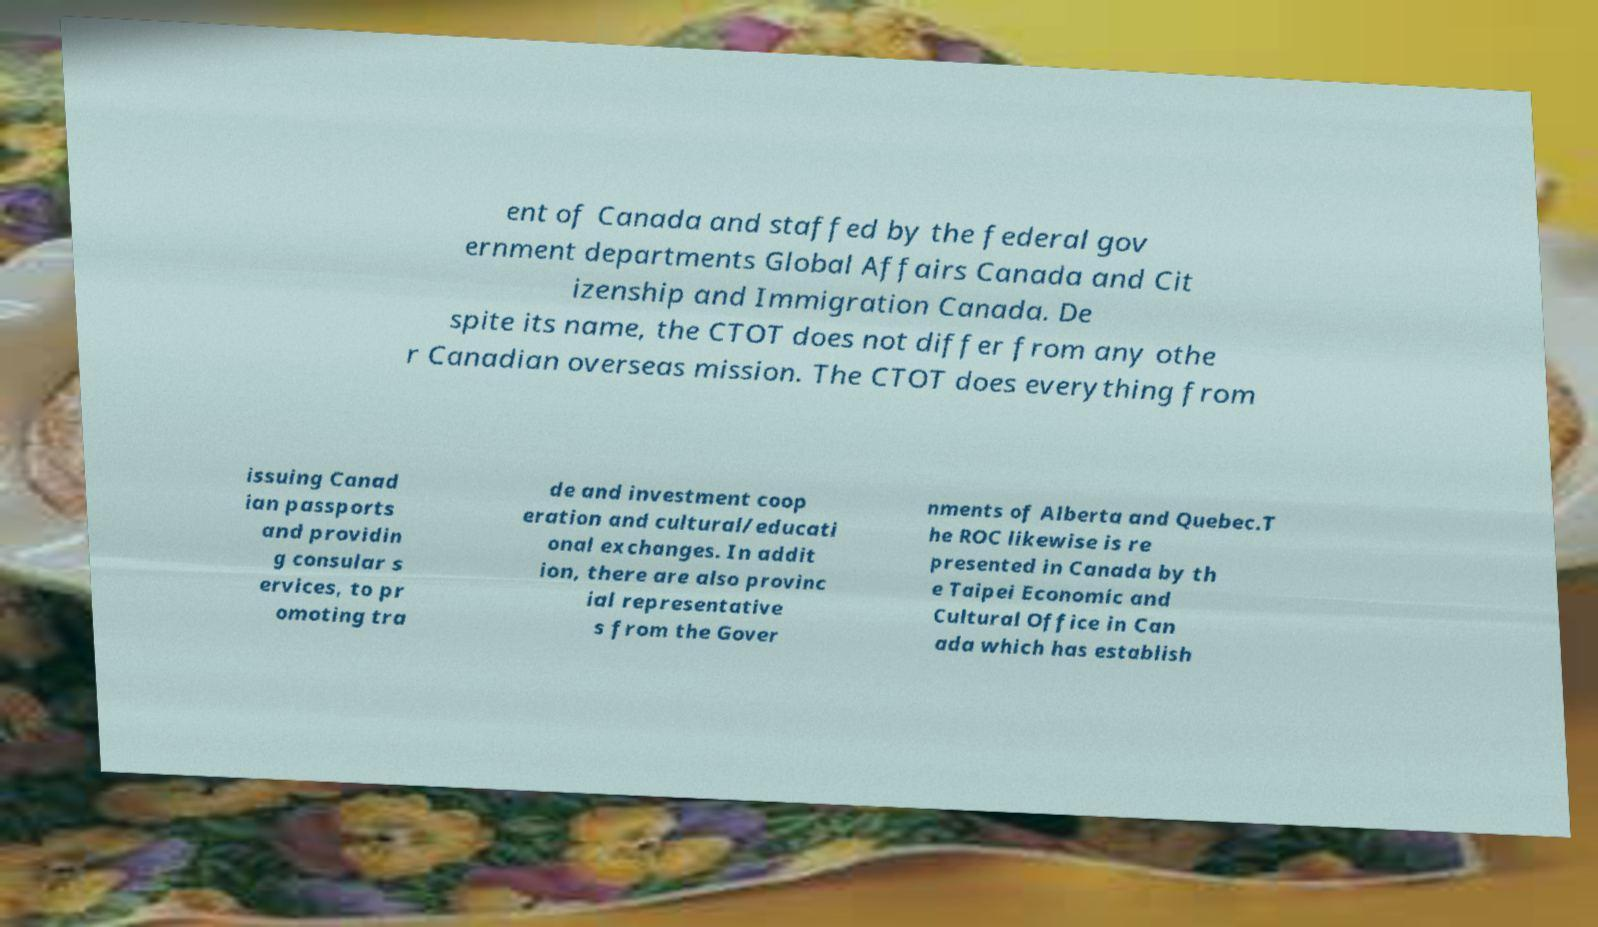There's text embedded in this image that I need extracted. Can you transcribe it verbatim? ent of Canada and staffed by the federal gov ernment departments Global Affairs Canada and Cit izenship and Immigration Canada. De spite its name, the CTOT does not differ from any othe r Canadian overseas mission. The CTOT does everything from issuing Canad ian passports and providin g consular s ervices, to pr omoting tra de and investment coop eration and cultural/educati onal exchanges. In addit ion, there are also provinc ial representative s from the Gover nments of Alberta and Quebec.T he ROC likewise is re presented in Canada by th e Taipei Economic and Cultural Office in Can ada which has establish 